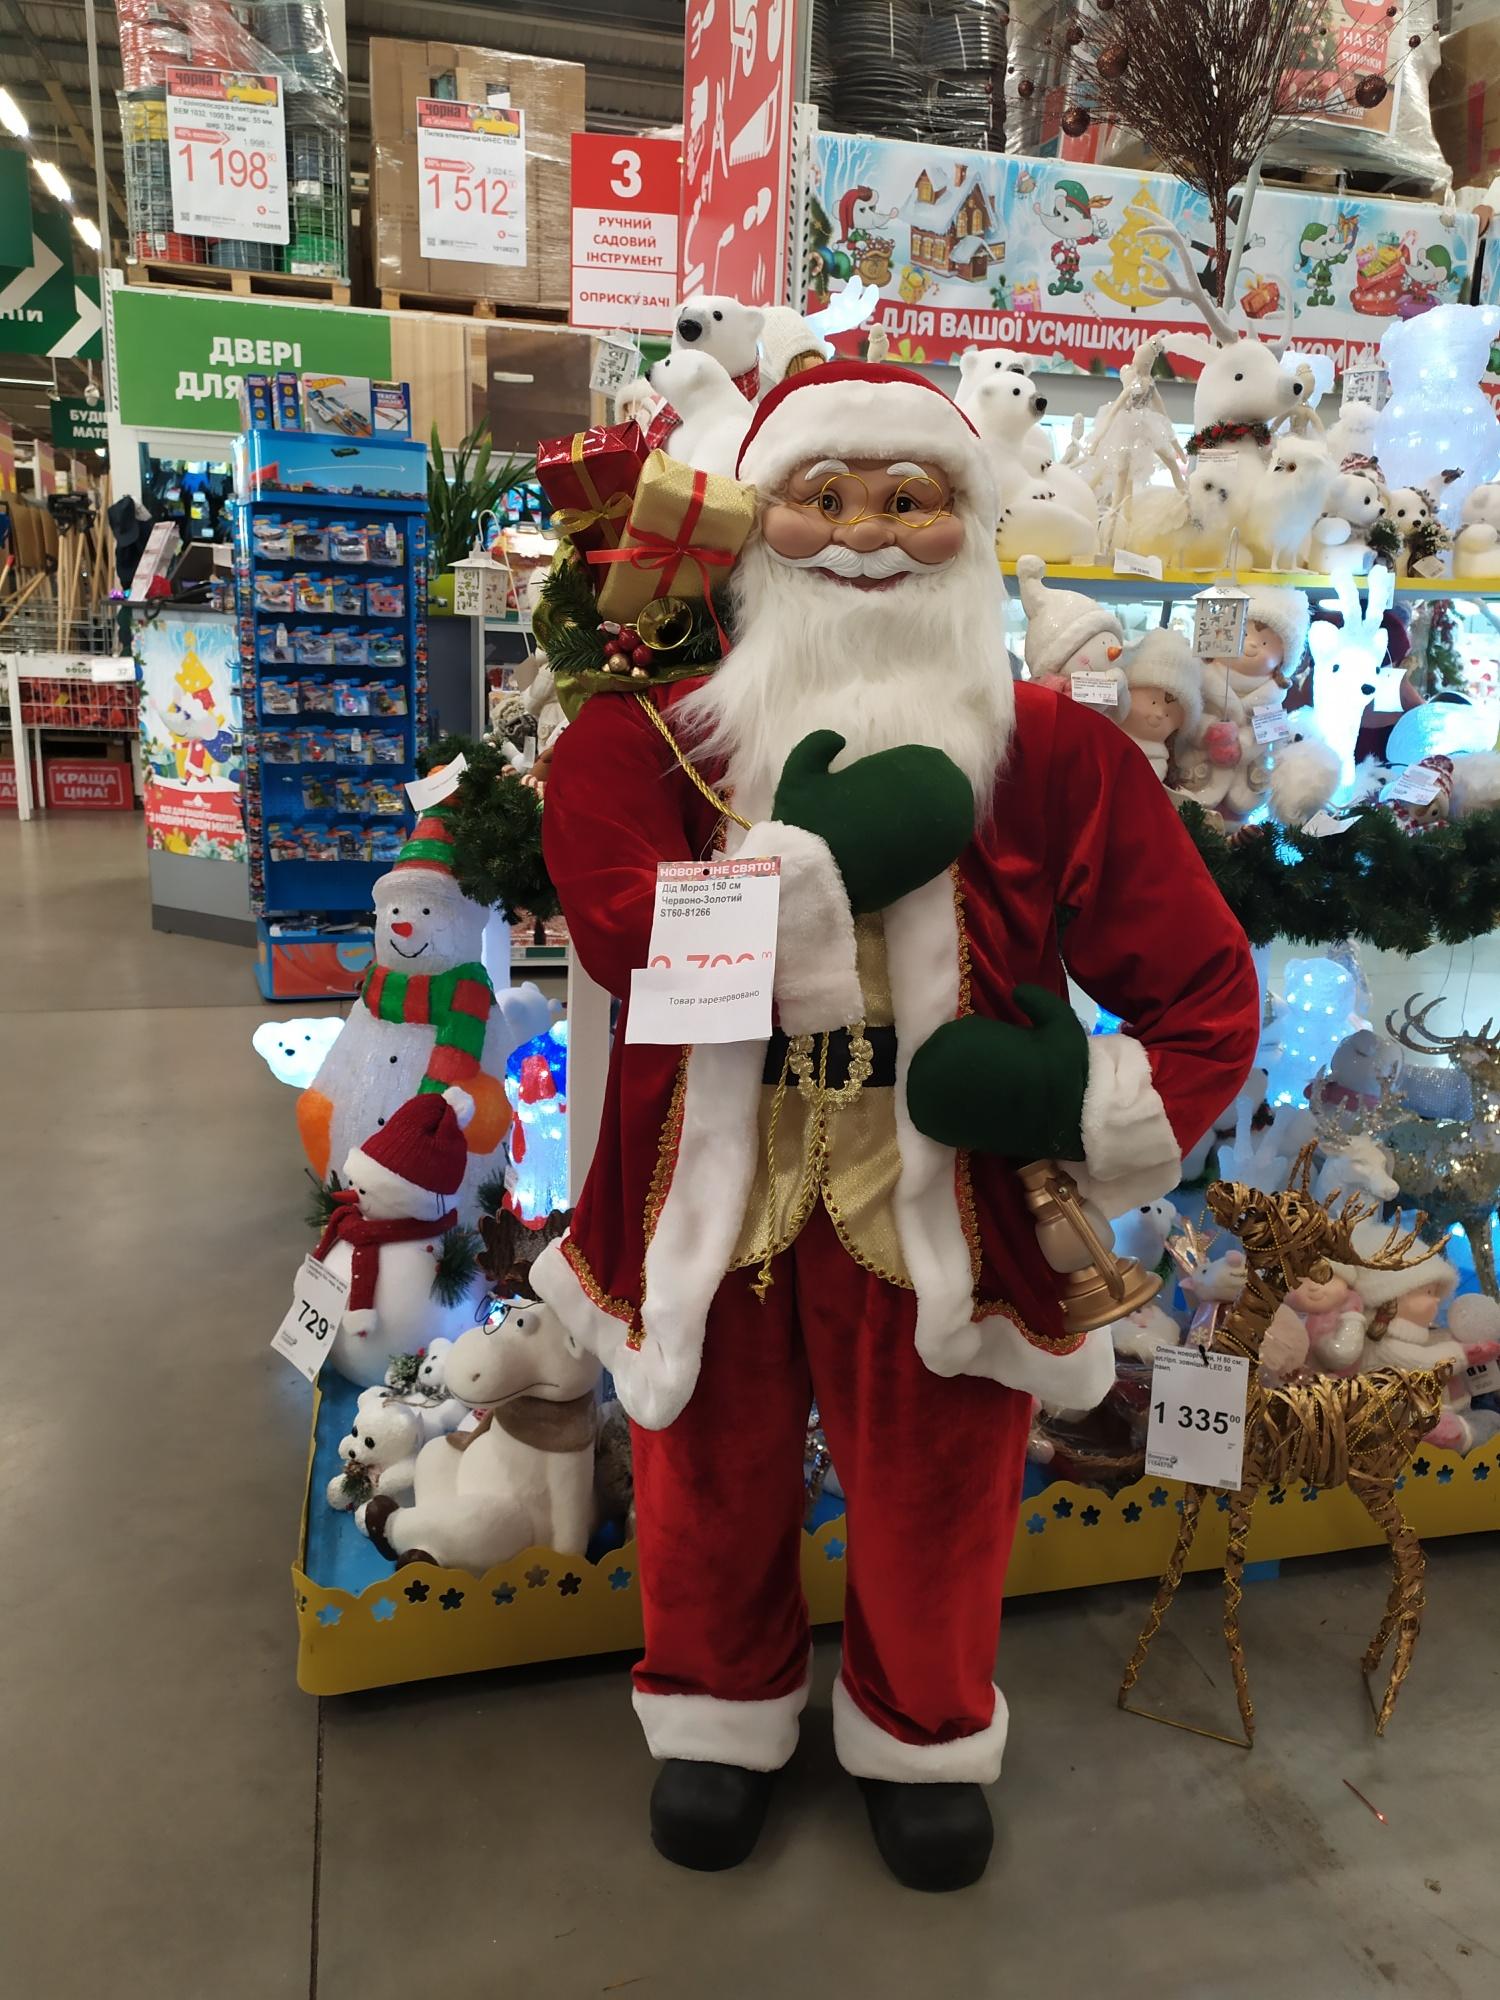Explain the visual content of the image in great detail. In the forefront of the image, a life-size figure of Santa Claus is prominently displayed in a store aisle. Santa is attired in his traditional red suit trimmed with white fur, a black belt with a golden buckle, and black boots. He holds an ornate, golden bell in one hand and a meticulously detailed list in the other. Draped over his shoulder is a festive green sack bearing a wrapped present and a decorative wreath.

Behind Santa, a dense display of various plush animals and vibrant Christmas decorations creates a festive backdrop. Christmas lights and ornaments abound, enhancing the holiday atmosphere. To the right of Santa, a well-lit reindeer decoration is visible.

The aisle itself is bustling with an array of holiday merchandise, with shelves stocked to the brim. Above, signage in Russian reads "Новый год" which translates to "New Year," indicating the global celebration of the holiday season. The text suggests the presence of New Year-themed decorations, typical in many countries, especially within the former Soviet Union. The signs guiding shoppers hang from the ceiling, aiding in store navigation.

All around, the store exudes festive cheer, making the larger-than-life Santa Claus figure the focal point amidst the rich tapestry of holiday décor. 